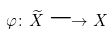<formula> <loc_0><loc_0><loc_500><loc_500>\varphi \colon \widetilde { X } \longrightarrow X</formula> 